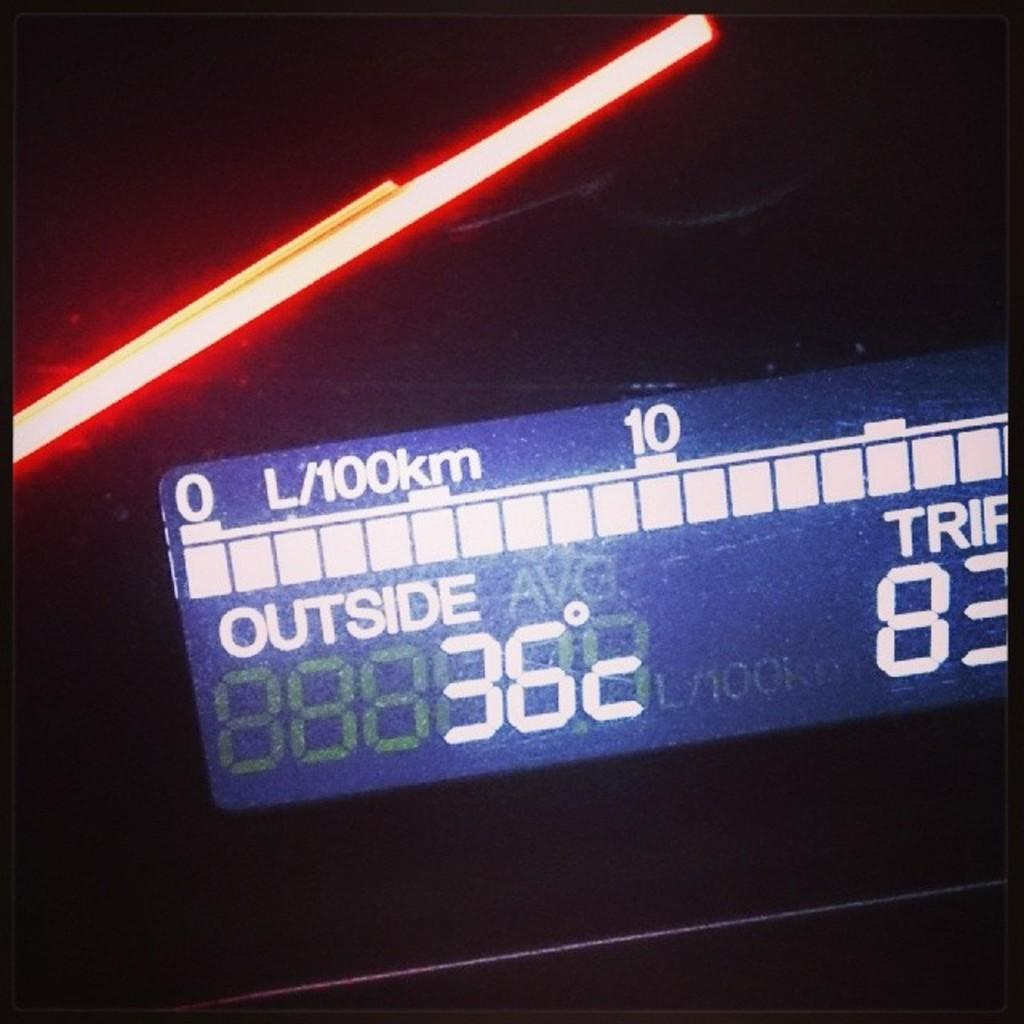<image>
Render a clear and concise summary of the photo. Screen that says the temperature outside at 36. 